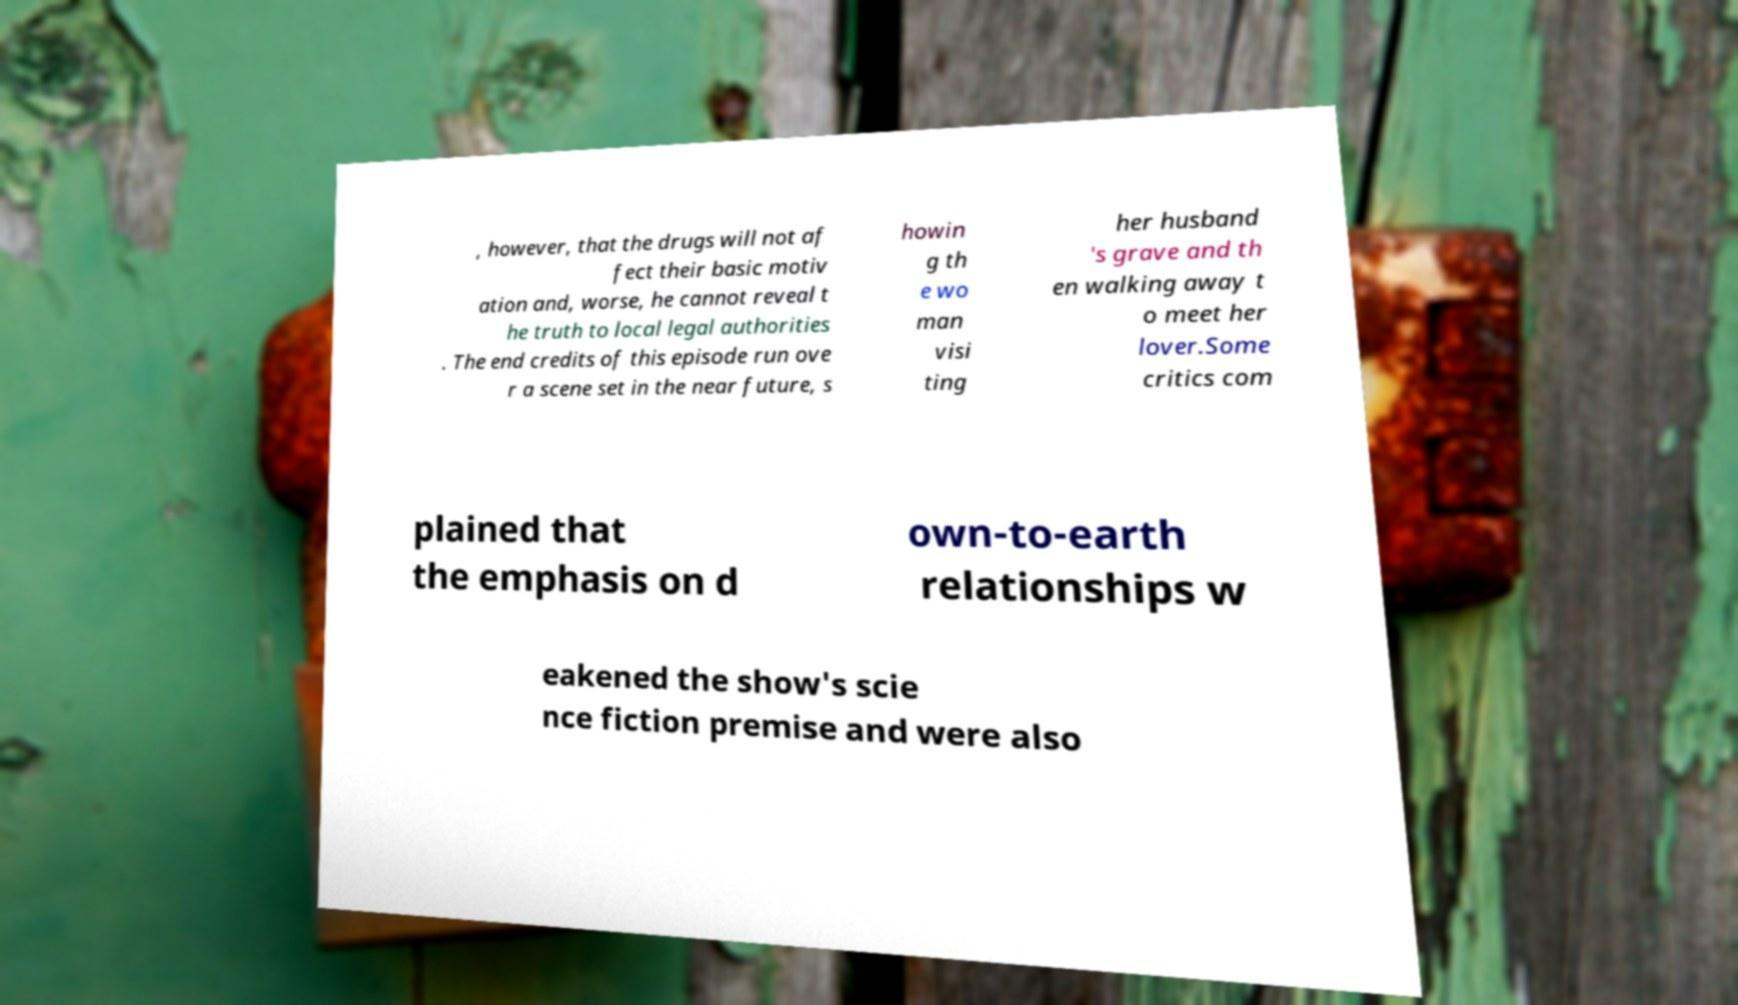What messages or text are displayed in this image? I need them in a readable, typed format. , however, that the drugs will not af fect their basic motiv ation and, worse, he cannot reveal t he truth to local legal authorities . The end credits of this episode run ove r a scene set in the near future, s howin g th e wo man visi ting her husband 's grave and th en walking away t o meet her lover.Some critics com plained that the emphasis on d own-to-earth relationships w eakened the show's scie nce fiction premise and were also 